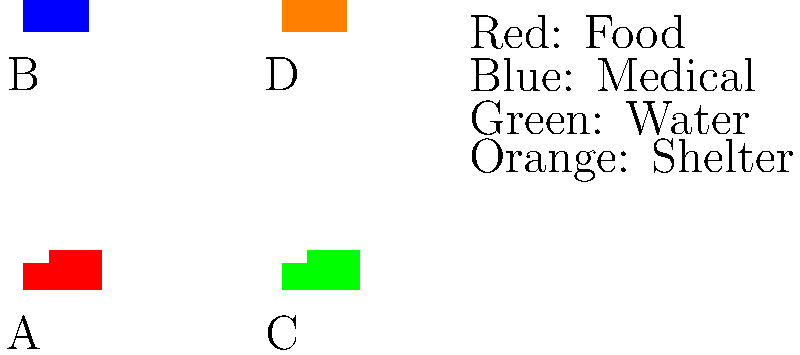Based on the security camera footage showing different humanitarian aid vehicles, which vehicle is most likely carrying water supplies to a post-conflict zone? To identify the vehicle most likely carrying water supplies, we need to analyze the given information and the graphic:

1. The graphic shows four different vehicles labeled A, B, C, and D.
2. Each vehicle is represented by a different color: red, blue, green, and orange.
3. The legend provides information on what each color represents:
   - Red: Food
   - Blue: Medical
   - Green: Water
   - Orange: Shelter

4. We need to identify the green vehicle, as it represents water supplies.
5. Looking at the graphic, we can see that vehicle C is colored green.

Therefore, vehicle C is most likely carrying water supplies to the post-conflict zone.
Answer: C 